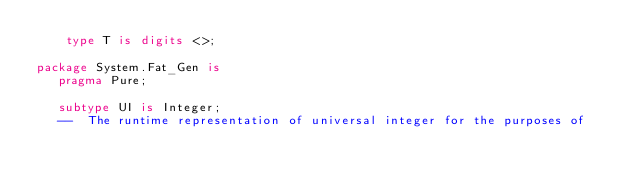Convert code to text. <code><loc_0><loc_0><loc_500><loc_500><_Ada_>    type T is digits <>;

package System.Fat_Gen is
   pragma Pure;

   subtype UI is Integer;
   --  The runtime representation of universal integer for the purposes of</code> 